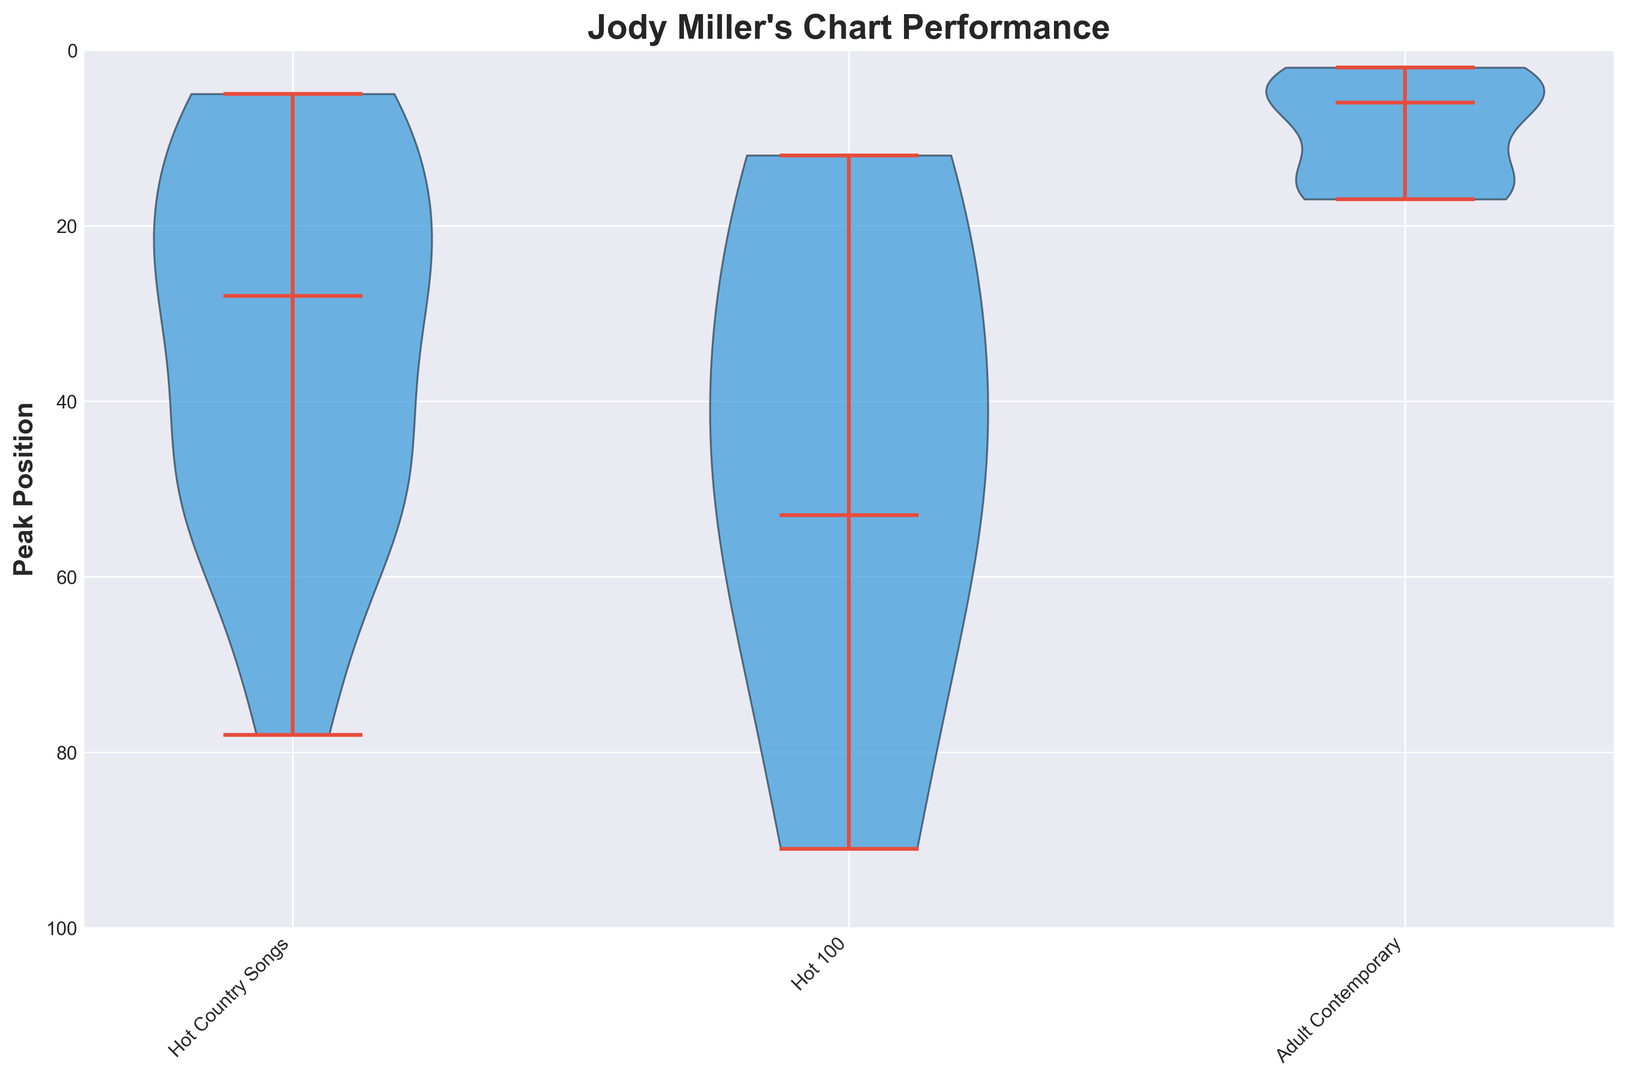How many charts show median peak positions above 20? The median peak position is visually represented by the red line in the violins. By looking at the figure, if the red line falls below the 20-mark for each chart, it signifies a median position above 20. The charts "Hot 100" and "Hot Country Songs" have red lines below the 20-mark.
Answer: 2 Which chart has the most spread in peak positions? The spread of peak positions can be assessed by looking at the width of the violins. The wider the violin, the more spread out the data. "Hot Country Songs" has the widest violin, indicating the most spread in peak positions.
Answer: Hot Country Songs Between 'Hot Country Songs' and 'Adult Contemporary' charts, which has better median peak positions? The red line in the violins represents the median peak position. 'Adult Contemporary' has a median line closer to the bottom, indicating better (lower) median peak positions than 'Hot Country Songs'.
Answer: Adult Contemporary What is the range of peak positions for the 'Hot Country Songs' chart? The range is determined by the highest and lowest points of the violin. For the 'Hot Country Songs', the lowest peak position is about 5, and the highest is about 78, giving a range of 5 to 78.
Answer: 5 to 78 Which chart has the best (lowest) median peak position? The chart with the median peak position closest to the bottom of the figure has the best median peak position. 'Adult Contemporary' has the median closest to the bottom, indicating the best (lowest) median peak position.
Answer: Adult Contemporary Is the interquartile range (IQR) of peak positions for the 'Hot 100' chart larger than that for the 'Adult Contemporary' chart? The IQR is indicated by the thickest part of the violin. Comparing the widths of the middle portions of these violins, 'Hot 100' has a thicker middle section (larger IQR) compared to 'Adult Contemporary'.
Answer: Yes Which chart shows more variability in peak positions? Variability can be inferred by looking at the overall width and size of the violin plots. 'Hot Country Songs' exhibits more variability with a wider and larger violin plot compared to the others.
Answer: Hot Country Songs What is the minimum peak position achieved on the 'Hot 100' chart? The minimum peak position can be seen at the bottom of the violin plot for 'Hot 100'. The lowest point reaches approximately 12, indicating the minimum peak position.
Answer: 12 Are there any charts where the median peak position is better than (lower than) 10? By looking at the red median line in the violin plots, if any line falls below the line marked 10, it indicates a median better than 10. 'Adult Contemporary' has a median below the 10-mark.
Answer: Yes Based on the chart medians, how do the 'Hot 100' and 'Adult Contemporary' charts perform in comparison to each other? Comparing the red median lines for 'Hot 100' and 'Adult Contemporary', 'Adult Contemporary' is closer to the bottom (better), indicating superior performance in terms of median peak positions.
Answer: Adult Contemporary performs better 